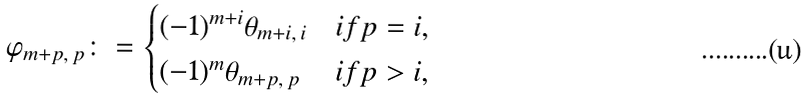<formula> <loc_0><loc_0><loc_500><loc_500>\varphi _ { m + p , \, p } \colon = \begin{cases} ( - 1 ) ^ { m + i } \theta _ { m + i , \, i } & i f p = i , \\ ( - 1 ) ^ { m } \theta _ { m + p , \, p } & i f p > i , \end{cases}</formula> 